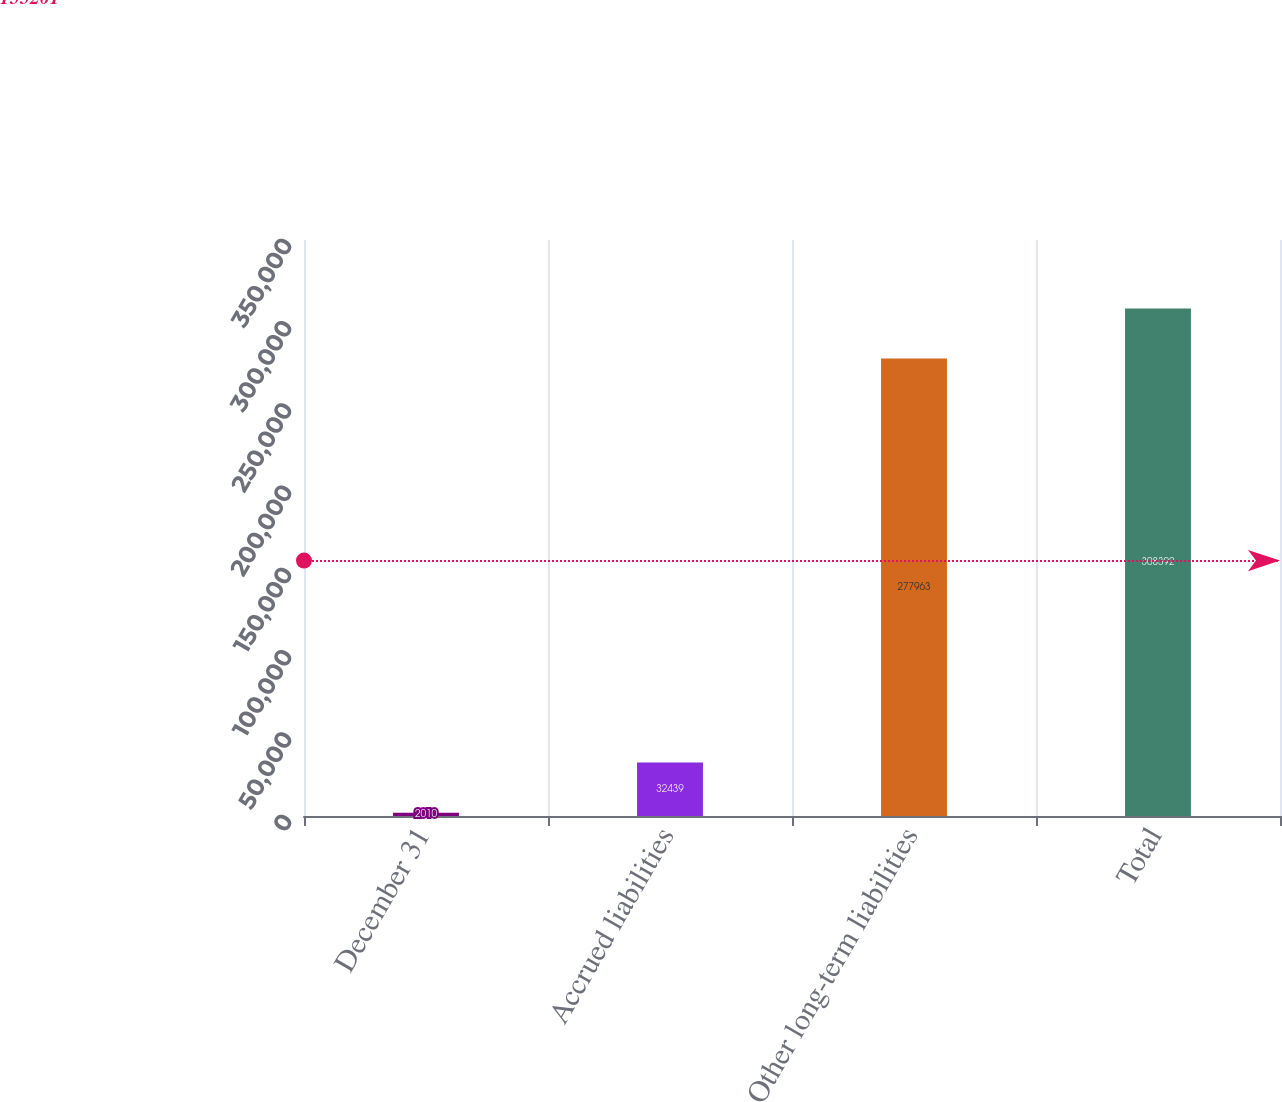Convert chart. <chart><loc_0><loc_0><loc_500><loc_500><bar_chart><fcel>December 31<fcel>Accrued liabilities<fcel>Other long-term liabilities<fcel>Total<nl><fcel>2010<fcel>32439<fcel>277963<fcel>308392<nl></chart> 